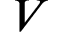<formula> <loc_0><loc_0><loc_500><loc_500>V</formula> 